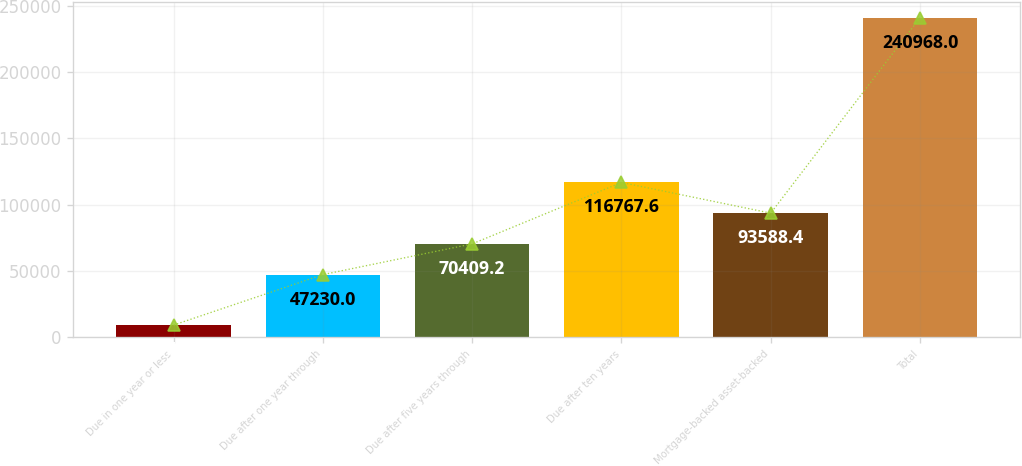<chart> <loc_0><loc_0><loc_500><loc_500><bar_chart><fcel>Due in one year or less<fcel>Due after one year through<fcel>Due after five years through<fcel>Due after ten years<fcel>Mortgage-backed asset-backed<fcel>Total<nl><fcel>9176<fcel>47230<fcel>70409.2<fcel>116768<fcel>93588.4<fcel>240968<nl></chart> 